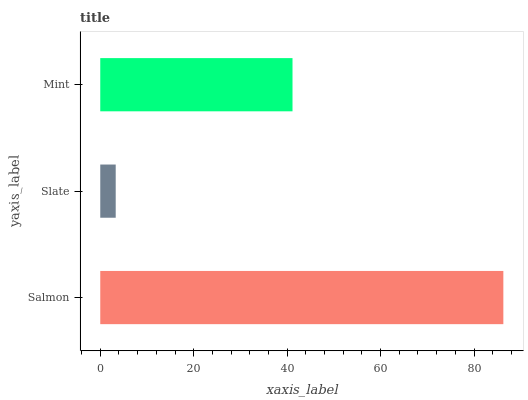Is Slate the minimum?
Answer yes or no. Yes. Is Salmon the maximum?
Answer yes or no. Yes. Is Mint the minimum?
Answer yes or no. No. Is Mint the maximum?
Answer yes or no. No. Is Mint greater than Slate?
Answer yes or no. Yes. Is Slate less than Mint?
Answer yes or no. Yes. Is Slate greater than Mint?
Answer yes or no. No. Is Mint less than Slate?
Answer yes or no. No. Is Mint the high median?
Answer yes or no. Yes. Is Mint the low median?
Answer yes or no. Yes. Is Slate the high median?
Answer yes or no. No. Is Salmon the low median?
Answer yes or no. No. 